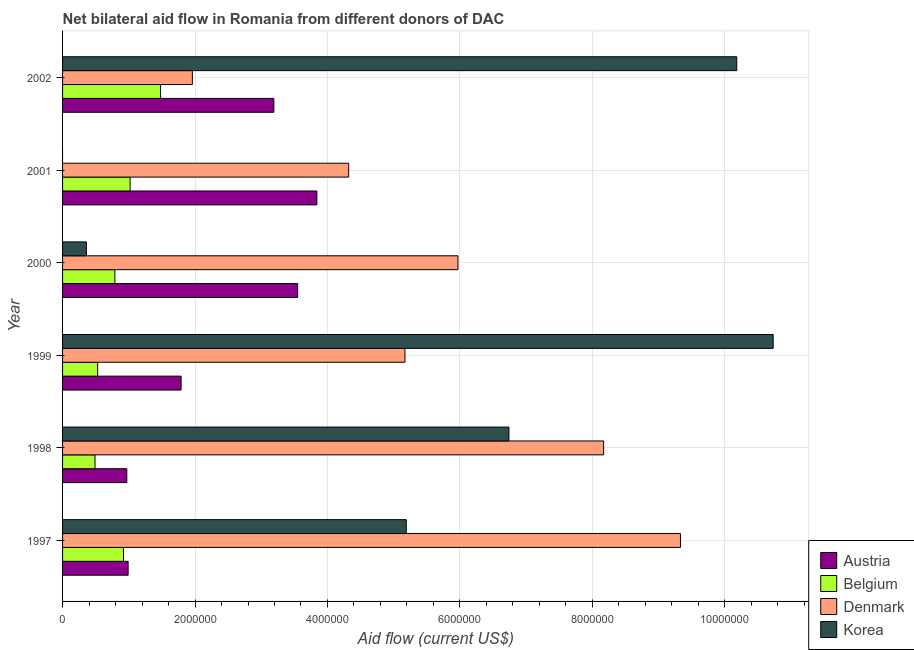How many different coloured bars are there?
Provide a succinct answer. 4. Are the number of bars per tick equal to the number of legend labels?
Your response must be concise. No. How many bars are there on the 2nd tick from the top?
Your response must be concise. 3. In how many cases, is the number of bars for a given year not equal to the number of legend labels?
Offer a terse response. 1. What is the amount of aid given by belgium in 2002?
Ensure brevity in your answer.  1.48e+06. Across all years, what is the maximum amount of aid given by austria?
Provide a short and direct response. 3.84e+06. In which year was the amount of aid given by korea maximum?
Your answer should be very brief. 1999. What is the total amount of aid given by austria in the graph?
Provide a succinct answer. 1.43e+07. What is the difference between the amount of aid given by belgium in 1998 and that in 1999?
Offer a very short reply. -4.00e+04. What is the difference between the amount of aid given by austria in 2002 and the amount of aid given by denmark in 1998?
Offer a terse response. -4.98e+06. What is the average amount of aid given by belgium per year?
Ensure brevity in your answer.  8.72e+05. In the year 1997, what is the difference between the amount of aid given by korea and amount of aid given by denmark?
Your answer should be very brief. -4.14e+06. What is the ratio of the amount of aid given by denmark in 2000 to that in 2002?
Keep it short and to the point. 3.05. Is the amount of aid given by belgium in 1997 less than that in 2001?
Your answer should be very brief. Yes. What is the difference between the highest and the lowest amount of aid given by belgium?
Offer a very short reply. 9.90e+05. In how many years, is the amount of aid given by belgium greater than the average amount of aid given by belgium taken over all years?
Provide a succinct answer. 3. Is the sum of the amount of aid given by denmark in 1999 and 2001 greater than the maximum amount of aid given by belgium across all years?
Your answer should be compact. Yes. Is it the case that in every year, the sum of the amount of aid given by austria and amount of aid given by belgium is greater than the amount of aid given by denmark?
Ensure brevity in your answer.  No. How many bars are there?
Your answer should be very brief. 23. What is the difference between two consecutive major ticks on the X-axis?
Make the answer very short. 2.00e+06. Are the values on the major ticks of X-axis written in scientific E-notation?
Offer a very short reply. No. Does the graph contain any zero values?
Your response must be concise. Yes. How are the legend labels stacked?
Provide a short and direct response. Vertical. What is the title of the graph?
Give a very brief answer. Net bilateral aid flow in Romania from different donors of DAC. What is the label or title of the X-axis?
Offer a terse response. Aid flow (current US$). What is the Aid flow (current US$) of Austria in 1997?
Offer a very short reply. 9.90e+05. What is the Aid flow (current US$) of Belgium in 1997?
Provide a short and direct response. 9.20e+05. What is the Aid flow (current US$) of Denmark in 1997?
Your response must be concise. 9.33e+06. What is the Aid flow (current US$) of Korea in 1997?
Offer a very short reply. 5.19e+06. What is the Aid flow (current US$) of Austria in 1998?
Provide a short and direct response. 9.70e+05. What is the Aid flow (current US$) of Denmark in 1998?
Keep it short and to the point. 8.17e+06. What is the Aid flow (current US$) of Korea in 1998?
Your response must be concise. 6.74e+06. What is the Aid flow (current US$) of Austria in 1999?
Provide a succinct answer. 1.79e+06. What is the Aid flow (current US$) in Belgium in 1999?
Provide a short and direct response. 5.30e+05. What is the Aid flow (current US$) in Denmark in 1999?
Your answer should be compact. 5.17e+06. What is the Aid flow (current US$) in Korea in 1999?
Make the answer very short. 1.07e+07. What is the Aid flow (current US$) of Austria in 2000?
Make the answer very short. 3.55e+06. What is the Aid flow (current US$) in Belgium in 2000?
Provide a succinct answer. 7.90e+05. What is the Aid flow (current US$) of Denmark in 2000?
Ensure brevity in your answer.  5.97e+06. What is the Aid flow (current US$) of Korea in 2000?
Offer a terse response. 3.60e+05. What is the Aid flow (current US$) of Austria in 2001?
Your answer should be compact. 3.84e+06. What is the Aid flow (current US$) of Belgium in 2001?
Keep it short and to the point. 1.02e+06. What is the Aid flow (current US$) in Denmark in 2001?
Make the answer very short. 4.32e+06. What is the Aid flow (current US$) in Korea in 2001?
Offer a terse response. 0. What is the Aid flow (current US$) of Austria in 2002?
Ensure brevity in your answer.  3.19e+06. What is the Aid flow (current US$) in Belgium in 2002?
Offer a terse response. 1.48e+06. What is the Aid flow (current US$) of Denmark in 2002?
Keep it short and to the point. 1.96e+06. What is the Aid flow (current US$) in Korea in 2002?
Ensure brevity in your answer.  1.02e+07. Across all years, what is the maximum Aid flow (current US$) of Austria?
Give a very brief answer. 3.84e+06. Across all years, what is the maximum Aid flow (current US$) in Belgium?
Ensure brevity in your answer.  1.48e+06. Across all years, what is the maximum Aid flow (current US$) in Denmark?
Provide a short and direct response. 9.33e+06. Across all years, what is the maximum Aid flow (current US$) of Korea?
Provide a succinct answer. 1.07e+07. Across all years, what is the minimum Aid flow (current US$) of Austria?
Your response must be concise. 9.70e+05. Across all years, what is the minimum Aid flow (current US$) of Denmark?
Offer a very short reply. 1.96e+06. Across all years, what is the minimum Aid flow (current US$) in Korea?
Give a very brief answer. 0. What is the total Aid flow (current US$) of Austria in the graph?
Offer a very short reply. 1.43e+07. What is the total Aid flow (current US$) of Belgium in the graph?
Your response must be concise. 5.23e+06. What is the total Aid flow (current US$) of Denmark in the graph?
Keep it short and to the point. 3.49e+07. What is the total Aid flow (current US$) of Korea in the graph?
Ensure brevity in your answer.  3.32e+07. What is the difference between the Aid flow (current US$) in Austria in 1997 and that in 1998?
Make the answer very short. 2.00e+04. What is the difference between the Aid flow (current US$) of Denmark in 1997 and that in 1998?
Your answer should be very brief. 1.16e+06. What is the difference between the Aid flow (current US$) in Korea in 1997 and that in 1998?
Make the answer very short. -1.55e+06. What is the difference between the Aid flow (current US$) of Austria in 1997 and that in 1999?
Provide a short and direct response. -8.00e+05. What is the difference between the Aid flow (current US$) in Belgium in 1997 and that in 1999?
Ensure brevity in your answer.  3.90e+05. What is the difference between the Aid flow (current US$) in Denmark in 1997 and that in 1999?
Keep it short and to the point. 4.16e+06. What is the difference between the Aid flow (current US$) of Korea in 1997 and that in 1999?
Make the answer very short. -5.54e+06. What is the difference between the Aid flow (current US$) in Austria in 1997 and that in 2000?
Keep it short and to the point. -2.56e+06. What is the difference between the Aid flow (current US$) of Denmark in 1997 and that in 2000?
Your answer should be compact. 3.36e+06. What is the difference between the Aid flow (current US$) of Korea in 1997 and that in 2000?
Offer a very short reply. 4.83e+06. What is the difference between the Aid flow (current US$) in Austria in 1997 and that in 2001?
Your answer should be very brief. -2.85e+06. What is the difference between the Aid flow (current US$) of Denmark in 1997 and that in 2001?
Provide a succinct answer. 5.01e+06. What is the difference between the Aid flow (current US$) in Austria in 1997 and that in 2002?
Offer a very short reply. -2.20e+06. What is the difference between the Aid flow (current US$) in Belgium in 1997 and that in 2002?
Keep it short and to the point. -5.60e+05. What is the difference between the Aid flow (current US$) of Denmark in 1997 and that in 2002?
Make the answer very short. 7.37e+06. What is the difference between the Aid flow (current US$) of Korea in 1997 and that in 2002?
Your answer should be compact. -4.99e+06. What is the difference between the Aid flow (current US$) of Austria in 1998 and that in 1999?
Make the answer very short. -8.20e+05. What is the difference between the Aid flow (current US$) of Belgium in 1998 and that in 1999?
Your response must be concise. -4.00e+04. What is the difference between the Aid flow (current US$) of Denmark in 1998 and that in 1999?
Offer a terse response. 3.00e+06. What is the difference between the Aid flow (current US$) in Korea in 1998 and that in 1999?
Your response must be concise. -3.99e+06. What is the difference between the Aid flow (current US$) in Austria in 1998 and that in 2000?
Your answer should be very brief. -2.58e+06. What is the difference between the Aid flow (current US$) in Belgium in 1998 and that in 2000?
Your response must be concise. -3.00e+05. What is the difference between the Aid flow (current US$) of Denmark in 1998 and that in 2000?
Give a very brief answer. 2.20e+06. What is the difference between the Aid flow (current US$) of Korea in 1998 and that in 2000?
Provide a short and direct response. 6.38e+06. What is the difference between the Aid flow (current US$) in Austria in 1998 and that in 2001?
Provide a short and direct response. -2.87e+06. What is the difference between the Aid flow (current US$) in Belgium in 1998 and that in 2001?
Provide a short and direct response. -5.30e+05. What is the difference between the Aid flow (current US$) in Denmark in 1998 and that in 2001?
Provide a short and direct response. 3.85e+06. What is the difference between the Aid flow (current US$) of Austria in 1998 and that in 2002?
Give a very brief answer. -2.22e+06. What is the difference between the Aid flow (current US$) of Belgium in 1998 and that in 2002?
Keep it short and to the point. -9.90e+05. What is the difference between the Aid flow (current US$) in Denmark in 1998 and that in 2002?
Your answer should be very brief. 6.21e+06. What is the difference between the Aid flow (current US$) in Korea in 1998 and that in 2002?
Make the answer very short. -3.44e+06. What is the difference between the Aid flow (current US$) in Austria in 1999 and that in 2000?
Make the answer very short. -1.76e+06. What is the difference between the Aid flow (current US$) in Belgium in 1999 and that in 2000?
Provide a succinct answer. -2.60e+05. What is the difference between the Aid flow (current US$) in Denmark in 1999 and that in 2000?
Offer a terse response. -8.00e+05. What is the difference between the Aid flow (current US$) in Korea in 1999 and that in 2000?
Ensure brevity in your answer.  1.04e+07. What is the difference between the Aid flow (current US$) of Austria in 1999 and that in 2001?
Ensure brevity in your answer.  -2.05e+06. What is the difference between the Aid flow (current US$) in Belgium in 1999 and that in 2001?
Provide a short and direct response. -4.90e+05. What is the difference between the Aid flow (current US$) in Denmark in 1999 and that in 2001?
Your response must be concise. 8.50e+05. What is the difference between the Aid flow (current US$) of Austria in 1999 and that in 2002?
Provide a succinct answer. -1.40e+06. What is the difference between the Aid flow (current US$) of Belgium in 1999 and that in 2002?
Offer a very short reply. -9.50e+05. What is the difference between the Aid flow (current US$) in Denmark in 1999 and that in 2002?
Your answer should be compact. 3.21e+06. What is the difference between the Aid flow (current US$) in Korea in 1999 and that in 2002?
Keep it short and to the point. 5.50e+05. What is the difference between the Aid flow (current US$) of Belgium in 2000 and that in 2001?
Ensure brevity in your answer.  -2.30e+05. What is the difference between the Aid flow (current US$) of Denmark in 2000 and that in 2001?
Give a very brief answer. 1.65e+06. What is the difference between the Aid flow (current US$) of Belgium in 2000 and that in 2002?
Your answer should be very brief. -6.90e+05. What is the difference between the Aid flow (current US$) of Denmark in 2000 and that in 2002?
Offer a very short reply. 4.01e+06. What is the difference between the Aid flow (current US$) in Korea in 2000 and that in 2002?
Make the answer very short. -9.82e+06. What is the difference between the Aid flow (current US$) in Austria in 2001 and that in 2002?
Your response must be concise. 6.50e+05. What is the difference between the Aid flow (current US$) in Belgium in 2001 and that in 2002?
Offer a terse response. -4.60e+05. What is the difference between the Aid flow (current US$) of Denmark in 2001 and that in 2002?
Offer a terse response. 2.36e+06. What is the difference between the Aid flow (current US$) in Austria in 1997 and the Aid flow (current US$) in Belgium in 1998?
Keep it short and to the point. 5.00e+05. What is the difference between the Aid flow (current US$) in Austria in 1997 and the Aid flow (current US$) in Denmark in 1998?
Offer a very short reply. -7.18e+06. What is the difference between the Aid flow (current US$) in Austria in 1997 and the Aid flow (current US$) in Korea in 1998?
Your response must be concise. -5.75e+06. What is the difference between the Aid flow (current US$) in Belgium in 1997 and the Aid flow (current US$) in Denmark in 1998?
Provide a short and direct response. -7.25e+06. What is the difference between the Aid flow (current US$) in Belgium in 1997 and the Aid flow (current US$) in Korea in 1998?
Offer a terse response. -5.82e+06. What is the difference between the Aid flow (current US$) in Denmark in 1997 and the Aid flow (current US$) in Korea in 1998?
Ensure brevity in your answer.  2.59e+06. What is the difference between the Aid flow (current US$) in Austria in 1997 and the Aid flow (current US$) in Denmark in 1999?
Your response must be concise. -4.18e+06. What is the difference between the Aid flow (current US$) of Austria in 1997 and the Aid flow (current US$) of Korea in 1999?
Make the answer very short. -9.74e+06. What is the difference between the Aid flow (current US$) in Belgium in 1997 and the Aid flow (current US$) in Denmark in 1999?
Keep it short and to the point. -4.25e+06. What is the difference between the Aid flow (current US$) of Belgium in 1997 and the Aid flow (current US$) of Korea in 1999?
Offer a terse response. -9.81e+06. What is the difference between the Aid flow (current US$) of Denmark in 1997 and the Aid flow (current US$) of Korea in 1999?
Your answer should be very brief. -1.40e+06. What is the difference between the Aid flow (current US$) in Austria in 1997 and the Aid flow (current US$) in Denmark in 2000?
Provide a succinct answer. -4.98e+06. What is the difference between the Aid flow (current US$) in Austria in 1997 and the Aid flow (current US$) in Korea in 2000?
Provide a succinct answer. 6.30e+05. What is the difference between the Aid flow (current US$) of Belgium in 1997 and the Aid flow (current US$) of Denmark in 2000?
Give a very brief answer. -5.05e+06. What is the difference between the Aid flow (current US$) of Belgium in 1997 and the Aid flow (current US$) of Korea in 2000?
Make the answer very short. 5.60e+05. What is the difference between the Aid flow (current US$) in Denmark in 1997 and the Aid flow (current US$) in Korea in 2000?
Provide a succinct answer. 8.97e+06. What is the difference between the Aid flow (current US$) of Austria in 1997 and the Aid flow (current US$) of Belgium in 2001?
Give a very brief answer. -3.00e+04. What is the difference between the Aid flow (current US$) of Austria in 1997 and the Aid flow (current US$) of Denmark in 2001?
Offer a very short reply. -3.33e+06. What is the difference between the Aid flow (current US$) in Belgium in 1997 and the Aid flow (current US$) in Denmark in 2001?
Your answer should be compact. -3.40e+06. What is the difference between the Aid flow (current US$) of Austria in 1997 and the Aid flow (current US$) of Belgium in 2002?
Give a very brief answer. -4.90e+05. What is the difference between the Aid flow (current US$) of Austria in 1997 and the Aid flow (current US$) of Denmark in 2002?
Offer a very short reply. -9.70e+05. What is the difference between the Aid flow (current US$) in Austria in 1997 and the Aid flow (current US$) in Korea in 2002?
Your answer should be very brief. -9.19e+06. What is the difference between the Aid flow (current US$) in Belgium in 1997 and the Aid flow (current US$) in Denmark in 2002?
Provide a short and direct response. -1.04e+06. What is the difference between the Aid flow (current US$) of Belgium in 1997 and the Aid flow (current US$) of Korea in 2002?
Offer a very short reply. -9.26e+06. What is the difference between the Aid flow (current US$) of Denmark in 1997 and the Aid flow (current US$) of Korea in 2002?
Provide a short and direct response. -8.50e+05. What is the difference between the Aid flow (current US$) in Austria in 1998 and the Aid flow (current US$) in Belgium in 1999?
Give a very brief answer. 4.40e+05. What is the difference between the Aid flow (current US$) of Austria in 1998 and the Aid flow (current US$) of Denmark in 1999?
Your answer should be very brief. -4.20e+06. What is the difference between the Aid flow (current US$) in Austria in 1998 and the Aid flow (current US$) in Korea in 1999?
Your answer should be very brief. -9.76e+06. What is the difference between the Aid flow (current US$) in Belgium in 1998 and the Aid flow (current US$) in Denmark in 1999?
Provide a short and direct response. -4.68e+06. What is the difference between the Aid flow (current US$) in Belgium in 1998 and the Aid flow (current US$) in Korea in 1999?
Provide a short and direct response. -1.02e+07. What is the difference between the Aid flow (current US$) of Denmark in 1998 and the Aid flow (current US$) of Korea in 1999?
Offer a terse response. -2.56e+06. What is the difference between the Aid flow (current US$) in Austria in 1998 and the Aid flow (current US$) in Belgium in 2000?
Give a very brief answer. 1.80e+05. What is the difference between the Aid flow (current US$) in Austria in 1998 and the Aid flow (current US$) in Denmark in 2000?
Provide a succinct answer. -5.00e+06. What is the difference between the Aid flow (current US$) of Belgium in 1998 and the Aid flow (current US$) of Denmark in 2000?
Your response must be concise. -5.48e+06. What is the difference between the Aid flow (current US$) in Belgium in 1998 and the Aid flow (current US$) in Korea in 2000?
Offer a very short reply. 1.30e+05. What is the difference between the Aid flow (current US$) in Denmark in 1998 and the Aid flow (current US$) in Korea in 2000?
Make the answer very short. 7.81e+06. What is the difference between the Aid flow (current US$) of Austria in 1998 and the Aid flow (current US$) of Belgium in 2001?
Offer a very short reply. -5.00e+04. What is the difference between the Aid flow (current US$) in Austria in 1998 and the Aid flow (current US$) in Denmark in 2001?
Make the answer very short. -3.35e+06. What is the difference between the Aid flow (current US$) of Belgium in 1998 and the Aid flow (current US$) of Denmark in 2001?
Offer a very short reply. -3.83e+06. What is the difference between the Aid flow (current US$) in Austria in 1998 and the Aid flow (current US$) in Belgium in 2002?
Keep it short and to the point. -5.10e+05. What is the difference between the Aid flow (current US$) of Austria in 1998 and the Aid flow (current US$) of Denmark in 2002?
Provide a succinct answer. -9.90e+05. What is the difference between the Aid flow (current US$) in Austria in 1998 and the Aid flow (current US$) in Korea in 2002?
Make the answer very short. -9.21e+06. What is the difference between the Aid flow (current US$) in Belgium in 1998 and the Aid flow (current US$) in Denmark in 2002?
Offer a terse response. -1.47e+06. What is the difference between the Aid flow (current US$) in Belgium in 1998 and the Aid flow (current US$) in Korea in 2002?
Your response must be concise. -9.69e+06. What is the difference between the Aid flow (current US$) of Denmark in 1998 and the Aid flow (current US$) of Korea in 2002?
Make the answer very short. -2.01e+06. What is the difference between the Aid flow (current US$) of Austria in 1999 and the Aid flow (current US$) of Belgium in 2000?
Your response must be concise. 1.00e+06. What is the difference between the Aid flow (current US$) in Austria in 1999 and the Aid flow (current US$) in Denmark in 2000?
Your answer should be compact. -4.18e+06. What is the difference between the Aid flow (current US$) of Austria in 1999 and the Aid flow (current US$) of Korea in 2000?
Your response must be concise. 1.43e+06. What is the difference between the Aid flow (current US$) in Belgium in 1999 and the Aid flow (current US$) in Denmark in 2000?
Give a very brief answer. -5.44e+06. What is the difference between the Aid flow (current US$) in Belgium in 1999 and the Aid flow (current US$) in Korea in 2000?
Offer a very short reply. 1.70e+05. What is the difference between the Aid flow (current US$) of Denmark in 1999 and the Aid flow (current US$) of Korea in 2000?
Ensure brevity in your answer.  4.81e+06. What is the difference between the Aid flow (current US$) of Austria in 1999 and the Aid flow (current US$) of Belgium in 2001?
Ensure brevity in your answer.  7.70e+05. What is the difference between the Aid flow (current US$) in Austria in 1999 and the Aid flow (current US$) in Denmark in 2001?
Offer a terse response. -2.53e+06. What is the difference between the Aid flow (current US$) of Belgium in 1999 and the Aid flow (current US$) of Denmark in 2001?
Your answer should be very brief. -3.79e+06. What is the difference between the Aid flow (current US$) in Austria in 1999 and the Aid flow (current US$) in Korea in 2002?
Your response must be concise. -8.39e+06. What is the difference between the Aid flow (current US$) in Belgium in 1999 and the Aid flow (current US$) in Denmark in 2002?
Your response must be concise. -1.43e+06. What is the difference between the Aid flow (current US$) of Belgium in 1999 and the Aid flow (current US$) of Korea in 2002?
Your answer should be very brief. -9.65e+06. What is the difference between the Aid flow (current US$) of Denmark in 1999 and the Aid flow (current US$) of Korea in 2002?
Give a very brief answer. -5.01e+06. What is the difference between the Aid flow (current US$) in Austria in 2000 and the Aid flow (current US$) in Belgium in 2001?
Your response must be concise. 2.53e+06. What is the difference between the Aid flow (current US$) in Austria in 2000 and the Aid flow (current US$) in Denmark in 2001?
Make the answer very short. -7.70e+05. What is the difference between the Aid flow (current US$) in Belgium in 2000 and the Aid flow (current US$) in Denmark in 2001?
Ensure brevity in your answer.  -3.53e+06. What is the difference between the Aid flow (current US$) in Austria in 2000 and the Aid flow (current US$) in Belgium in 2002?
Offer a terse response. 2.07e+06. What is the difference between the Aid flow (current US$) of Austria in 2000 and the Aid flow (current US$) of Denmark in 2002?
Offer a terse response. 1.59e+06. What is the difference between the Aid flow (current US$) of Austria in 2000 and the Aid flow (current US$) of Korea in 2002?
Your answer should be very brief. -6.63e+06. What is the difference between the Aid flow (current US$) in Belgium in 2000 and the Aid flow (current US$) in Denmark in 2002?
Keep it short and to the point. -1.17e+06. What is the difference between the Aid flow (current US$) in Belgium in 2000 and the Aid flow (current US$) in Korea in 2002?
Ensure brevity in your answer.  -9.39e+06. What is the difference between the Aid flow (current US$) of Denmark in 2000 and the Aid flow (current US$) of Korea in 2002?
Your answer should be very brief. -4.21e+06. What is the difference between the Aid flow (current US$) of Austria in 2001 and the Aid flow (current US$) of Belgium in 2002?
Keep it short and to the point. 2.36e+06. What is the difference between the Aid flow (current US$) of Austria in 2001 and the Aid flow (current US$) of Denmark in 2002?
Your response must be concise. 1.88e+06. What is the difference between the Aid flow (current US$) of Austria in 2001 and the Aid flow (current US$) of Korea in 2002?
Your response must be concise. -6.34e+06. What is the difference between the Aid flow (current US$) in Belgium in 2001 and the Aid flow (current US$) in Denmark in 2002?
Offer a terse response. -9.40e+05. What is the difference between the Aid flow (current US$) in Belgium in 2001 and the Aid flow (current US$) in Korea in 2002?
Keep it short and to the point. -9.16e+06. What is the difference between the Aid flow (current US$) in Denmark in 2001 and the Aid flow (current US$) in Korea in 2002?
Your answer should be very brief. -5.86e+06. What is the average Aid flow (current US$) in Austria per year?
Provide a short and direct response. 2.39e+06. What is the average Aid flow (current US$) in Belgium per year?
Provide a short and direct response. 8.72e+05. What is the average Aid flow (current US$) of Denmark per year?
Give a very brief answer. 5.82e+06. What is the average Aid flow (current US$) in Korea per year?
Ensure brevity in your answer.  5.53e+06. In the year 1997, what is the difference between the Aid flow (current US$) of Austria and Aid flow (current US$) of Belgium?
Ensure brevity in your answer.  7.00e+04. In the year 1997, what is the difference between the Aid flow (current US$) in Austria and Aid flow (current US$) in Denmark?
Your response must be concise. -8.34e+06. In the year 1997, what is the difference between the Aid flow (current US$) in Austria and Aid flow (current US$) in Korea?
Your response must be concise. -4.20e+06. In the year 1997, what is the difference between the Aid flow (current US$) in Belgium and Aid flow (current US$) in Denmark?
Your answer should be compact. -8.41e+06. In the year 1997, what is the difference between the Aid flow (current US$) in Belgium and Aid flow (current US$) in Korea?
Provide a short and direct response. -4.27e+06. In the year 1997, what is the difference between the Aid flow (current US$) of Denmark and Aid flow (current US$) of Korea?
Give a very brief answer. 4.14e+06. In the year 1998, what is the difference between the Aid flow (current US$) of Austria and Aid flow (current US$) of Belgium?
Offer a very short reply. 4.80e+05. In the year 1998, what is the difference between the Aid flow (current US$) of Austria and Aid flow (current US$) of Denmark?
Your response must be concise. -7.20e+06. In the year 1998, what is the difference between the Aid flow (current US$) in Austria and Aid flow (current US$) in Korea?
Offer a terse response. -5.77e+06. In the year 1998, what is the difference between the Aid flow (current US$) in Belgium and Aid flow (current US$) in Denmark?
Keep it short and to the point. -7.68e+06. In the year 1998, what is the difference between the Aid flow (current US$) in Belgium and Aid flow (current US$) in Korea?
Ensure brevity in your answer.  -6.25e+06. In the year 1998, what is the difference between the Aid flow (current US$) of Denmark and Aid flow (current US$) of Korea?
Ensure brevity in your answer.  1.43e+06. In the year 1999, what is the difference between the Aid flow (current US$) of Austria and Aid flow (current US$) of Belgium?
Your answer should be compact. 1.26e+06. In the year 1999, what is the difference between the Aid flow (current US$) of Austria and Aid flow (current US$) of Denmark?
Your answer should be very brief. -3.38e+06. In the year 1999, what is the difference between the Aid flow (current US$) of Austria and Aid flow (current US$) of Korea?
Make the answer very short. -8.94e+06. In the year 1999, what is the difference between the Aid flow (current US$) in Belgium and Aid flow (current US$) in Denmark?
Offer a terse response. -4.64e+06. In the year 1999, what is the difference between the Aid flow (current US$) of Belgium and Aid flow (current US$) of Korea?
Ensure brevity in your answer.  -1.02e+07. In the year 1999, what is the difference between the Aid flow (current US$) in Denmark and Aid flow (current US$) in Korea?
Your response must be concise. -5.56e+06. In the year 2000, what is the difference between the Aid flow (current US$) of Austria and Aid flow (current US$) of Belgium?
Keep it short and to the point. 2.76e+06. In the year 2000, what is the difference between the Aid flow (current US$) of Austria and Aid flow (current US$) of Denmark?
Offer a very short reply. -2.42e+06. In the year 2000, what is the difference between the Aid flow (current US$) of Austria and Aid flow (current US$) of Korea?
Provide a short and direct response. 3.19e+06. In the year 2000, what is the difference between the Aid flow (current US$) in Belgium and Aid flow (current US$) in Denmark?
Ensure brevity in your answer.  -5.18e+06. In the year 2000, what is the difference between the Aid flow (current US$) of Belgium and Aid flow (current US$) of Korea?
Keep it short and to the point. 4.30e+05. In the year 2000, what is the difference between the Aid flow (current US$) in Denmark and Aid flow (current US$) in Korea?
Provide a short and direct response. 5.61e+06. In the year 2001, what is the difference between the Aid flow (current US$) of Austria and Aid flow (current US$) of Belgium?
Provide a succinct answer. 2.82e+06. In the year 2001, what is the difference between the Aid flow (current US$) of Austria and Aid flow (current US$) of Denmark?
Your response must be concise. -4.80e+05. In the year 2001, what is the difference between the Aid flow (current US$) of Belgium and Aid flow (current US$) of Denmark?
Ensure brevity in your answer.  -3.30e+06. In the year 2002, what is the difference between the Aid flow (current US$) in Austria and Aid flow (current US$) in Belgium?
Ensure brevity in your answer.  1.71e+06. In the year 2002, what is the difference between the Aid flow (current US$) in Austria and Aid flow (current US$) in Denmark?
Keep it short and to the point. 1.23e+06. In the year 2002, what is the difference between the Aid flow (current US$) in Austria and Aid flow (current US$) in Korea?
Ensure brevity in your answer.  -6.99e+06. In the year 2002, what is the difference between the Aid flow (current US$) of Belgium and Aid flow (current US$) of Denmark?
Ensure brevity in your answer.  -4.80e+05. In the year 2002, what is the difference between the Aid flow (current US$) of Belgium and Aid flow (current US$) of Korea?
Offer a very short reply. -8.70e+06. In the year 2002, what is the difference between the Aid flow (current US$) of Denmark and Aid flow (current US$) of Korea?
Your answer should be compact. -8.22e+06. What is the ratio of the Aid flow (current US$) in Austria in 1997 to that in 1998?
Your answer should be compact. 1.02. What is the ratio of the Aid flow (current US$) in Belgium in 1997 to that in 1998?
Ensure brevity in your answer.  1.88. What is the ratio of the Aid flow (current US$) in Denmark in 1997 to that in 1998?
Give a very brief answer. 1.14. What is the ratio of the Aid flow (current US$) in Korea in 1997 to that in 1998?
Give a very brief answer. 0.77. What is the ratio of the Aid flow (current US$) of Austria in 1997 to that in 1999?
Your response must be concise. 0.55. What is the ratio of the Aid flow (current US$) in Belgium in 1997 to that in 1999?
Offer a terse response. 1.74. What is the ratio of the Aid flow (current US$) of Denmark in 1997 to that in 1999?
Your response must be concise. 1.8. What is the ratio of the Aid flow (current US$) of Korea in 1997 to that in 1999?
Offer a very short reply. 0.48. What is the ratio of the Aid flow (current US$) of Austria in 1997 to that in 2000?
Offer a very short reply. 0.28. What is the ratio of the Aid flow (current US$) of Belgium in 1997 to that in 2000?
Keep it short and to the point. 1.16. What is the ratio of the Aid flow (current US$) in Denmark in 1997 to that in 2000?
Your answer should be very brief. 1.56. What is the ratio of the Aid flow (current US$) in Korea in 1997 to that in 2000?
Your answer should be compact. 14.42. What is the ratio of the Aid flow (current US$) in Austria in 1997 to that in 2001?
Your answer should be very brief. 0.26. What is the ratio of the Aid flow (current US$) in Belgium in 1997 to that in 2001?
Ensure brevity in your answer.  0.9. What is the ratio of the Aid flow (current US$) of Denmark in 1997 to that in 2001?
Provide a succinct answer. 2.16. What is the ratio of the Aid flow (current US$) in Austria in 1997 to that in 2002?
Offer a very short reply. 0.31. What is the ratio of the Aid flow (current US$) in Belgium in 1997 to that in 2002?
Your answer should be very brief. 0.62. What is the ratio of the Aid flow (current US$) in Denmark in 1997 to that in 2002?
Ensure brevity in your answer.  4.76. What is the ratio of the Aid flow (current US$) of Korea in 1997 to that in 2002?
Keep it short and to the point. 0.51. What is the ratio of the Aid flow (current US$) of Austria in 1998 to that in 1999?
Provide a short and direct response. 0.54. What is the ratio of the Aid flow (current US$) in Belgium in 1998 to that in 1999?
Offer a terse response. 0.92. What is the ratio of the Aid flow (current US$) of Denmark in 1998 to that in 1999?
Your answer should be compact. 1.58. What is the ratio of the Aid flow (current US$) of Korea in 1998 to that in 1999?
Offer a very short reply. 0.63. What is the ratio of the Aid flow (current US$) of Austria in 1998 to that in 2000?
Your answer should be compact. 0.27. What is the ratio of the Aid flow (current US$) in Belgium in 1998 to that in 2000?
Offer a very short reply. 0.62. What is the ratio of the Aid flow (current US$) of Denmark in 1998 to that in 2000?
Your answer should be compact. 1.37. What is the ratio of the Aid flow (current US$) in Korea in 1998 to that in 2000?
Make the answer very short. 18.72. What is the ratio of the Aid flow (current US$) of Austria in 1998 to that in 2001?
Your answer should be compact. 0.25. What is the ratio of the Aid flow (current US$) in Belgium in 1998 to that in 2001?
Your answer should be very brief. 0.48. What is the ratio of the Aid flow (current US$) of Denmark in 1998 to that in 2001?
Give a very brief answer. 1.89. What is the ratio of the Aid flow (current US$) in Austria in 1998 to that in 2002?
Make the answer very short. 0.3. What is the ratio of the Aid flow (current US$) in Belgium in 1998 to that in 2002?
Provide a short and direct response. 0.33. What is the ratio of the Aid flow (current US$) in Denmark in 1998 to that in 2002?
Offer a very short reply. 4.17. What is the ratio of the Aid flow (current US$) in Korea in 1998 to that in 2002?
Provide a short and direct response. 0.66. What is the ratio of the Aid flow (current US$) of Austria in 1999 to that in 2000?
Provide a succinct answer. 0.5. What is the ratio of the Aid flow (current US$) of Belgium in 1999 to that in 2000?
Offer a very short reply. 0.67. What is the ratio of the Aid flow (current US$) in Denmark in 1999 to that in 2000?
Your response must be concise. 0.87. What is the ratio of the Aid flow (current US$) of Korea in 1999 to that in 2000?
Ensure brevity in your answer.  29.81. What is the ratio of the Aid flow (current US$) of Austria in 1999 to that in 2001?
Offer a terse response. 0.47. What is the ratio of the Aid flow (current US$) of Belgium in 1999 to that in 2001?
Make the answer very short. 0.52. What is the ratio of the Aid flow (current US$) of Denmark in 1999 to that in 2001?
Offer a very short reply. 1.2. What is the ratio of the Aid flow (current US$) of Austria in 1999 to that in 2002?
Offer a terse response. 0.56. What is the ratio of the Aid flow (current US$) of Belgium in 1999 to that in 2002?
Your answer should be very brief. 0.36. What is the ratio of the Aid flow (current US$) in Denmark in 1999 to that in 2002?
Ensure brevity in your answer.  2.64. What is the ratio of the Aid flow (current US$) in Korea in 1999 to that in 2002?
Offer a very short reply. 1.05. What is the ratio of the Aid flow (current US$) in Austria in 2000 to that in 2001?
Your response must be concise. 0.92. What is the ratio of the Aid flow (current US$) in Belgium in 2000 to that in 2001?
Your answer should be compact. 0.77. What is the ratio of the Aid flow (current US$) in Denmark in 2000 to that in 2001?
Ensure brevity in your answer.  1.38. What is the ratio of the Aid flow (current US$) in Austria in 2000 to that in 2002?
Make the answer very short. 1.11. What is the ratio of the Aid flow (current US$) in Belgium in 2000 to that in 2002?
Offer a very short reply. 0.53. What is the ratio of the Aid flow (current US$) of Denmark in 2000 to that in 2002?
Your answer should be very brief. 3.05. What is the ratio of the Aid flow (current US$) of Korea in 2000 to that in 2002?
Offer a very short reply. 0.04. What is the ratio of the Aid flow (current US$) in Austria in 2001 to that in 2002?
Your answer should be compact. 1.2. What is the ratio of the Aid flow (current US$) of Belgium in 2001 to that in 2002?
Provide a succinct answer. 0.69. What is the ratio of the Aid flow (current US$) of Denmark in 2001 to that in 2002?
Your response must be concise. 2.2. What is the difference between the highest and the second highest Aid flow (current US$) in Austria?
Your response must be concise. 2.90e+05. What is the difference between the highest and the second highest Aid flow (current US$) in Belgium?
Your answer should be compact. 4.60e+05. What is the difference between the highest and the second highest Aid flow (current US$) in Denmark?
Provide a succinct answer. 1.16e+06. What is the difference between the highest and the lowest Aid flow (current US$) of Austria?
Keep it short and to the point. 2.87e+06. What is the difference between the highest and the lowest Aid flow (current US$) in Belgium?
Offer a very short reply. 9.90e+05. What is the difference between the highest and the lowest Aid flow (current US$) in Denmark?
Your response must be concise. 7.37e+06. What is the difference between the highest and the lowest Aid flow (current US$) in Korea?
Ensure brevity in your answer.  1.07e+07. 